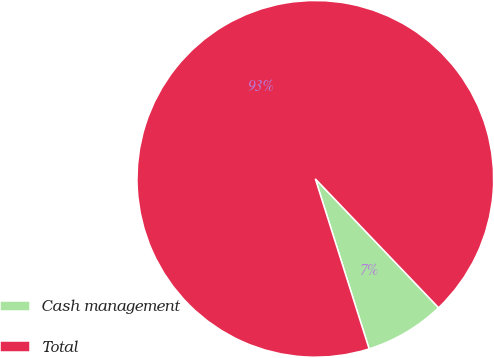<chart> <loc_0><loc_0><loc_500><loc_500><pie_chart><fcel>Cash management<fcel>Total<nl><fcel>7.27%<fcel>92.73%<nl></chart> 